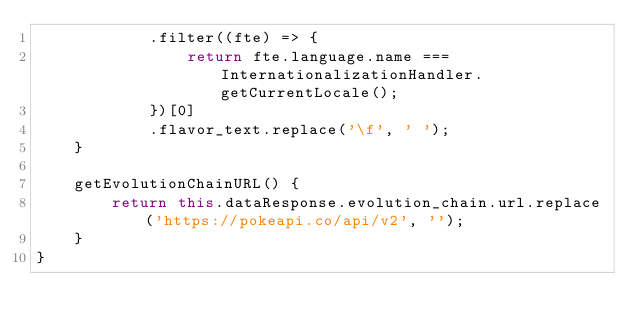Convert code to text. <code><loc_0><loc_0><loc_500><loc_500><_JavaScript_>            .filter((fte) => {
                return fte.language.name === InternationalizationHandler.getCurrentLocale();
            })[0]
            .flavor_text.replace('\f', ' ');
    }

    getEvolutionChainURL() {
        return this.dataResponse.evolution_chain.url.replace('https://pokeapi.co/api/v2', '');
    }
}
</code> 